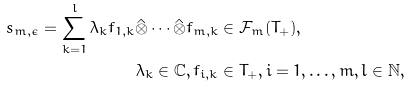Convert formula to latex. <formula><loc_0><loc_0><loc_500><loc_500>s _ { m , \epsilon } = \sum _ { k = 1 } ^ { l } \lambda _ { k } f _ { 1 , k } \hat { \otimes } \cdots \hat { \otimes } f _ { m , k } & \in \mathcal { F } _ { m } ( T _ { + } ) , \\ \lambda _ { k } \in \mathbb { C } , f _ { i , k } & \in T _ { + } , i = 1 , \dots , m , l \in \mathbb { N } ,</formula> 